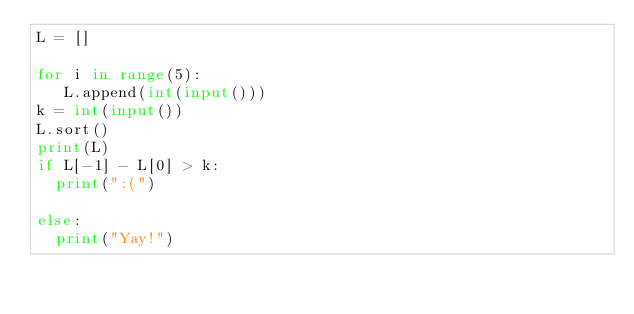Convert code to text. <code><loc_0><loc_0><loc_500><loc_500><_Python_>L = []

for i in range(5):
   L.append(int(input()))
k = int(input())
L.sort()
print(L)
if L[-1] - L[0] > k:
  print(":(")

else:
  print("Yay!")

</code> 